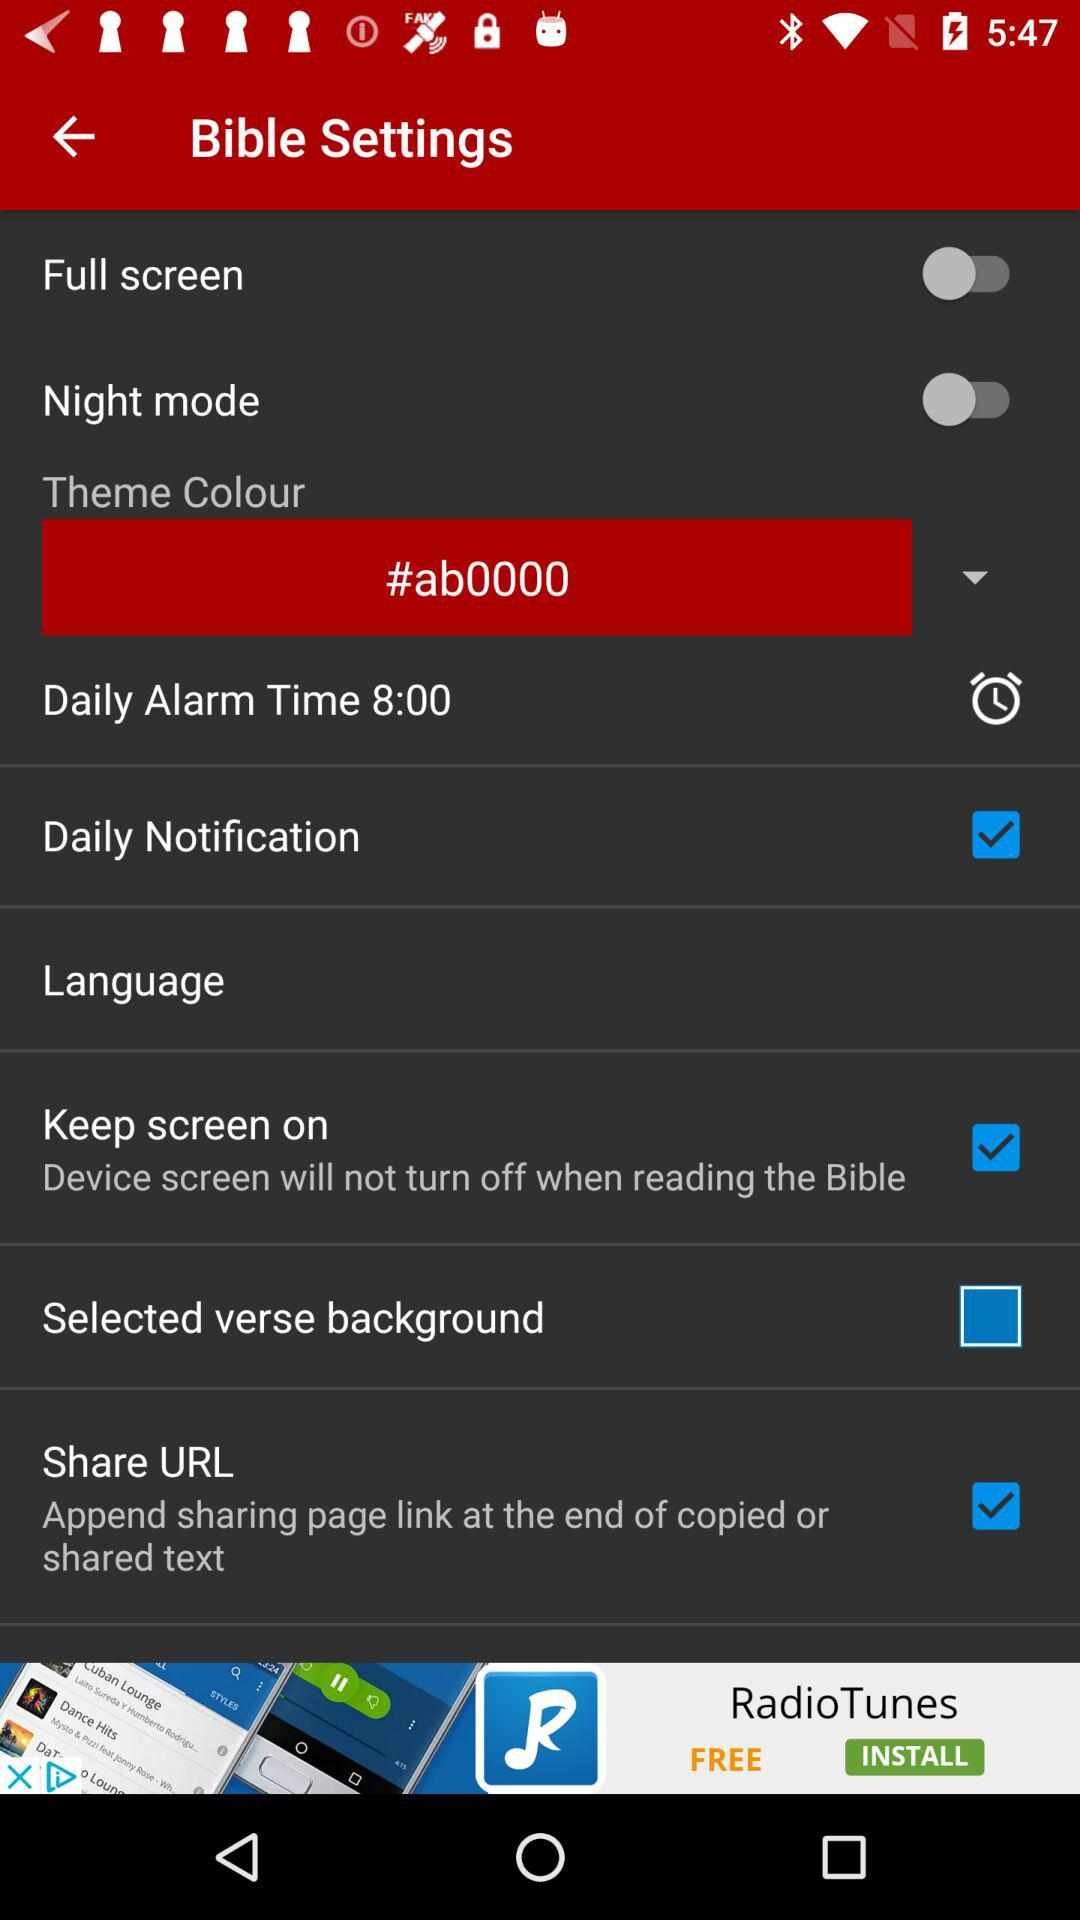For what time is the daily alarm set? The daily alarm is set for 8:00. 